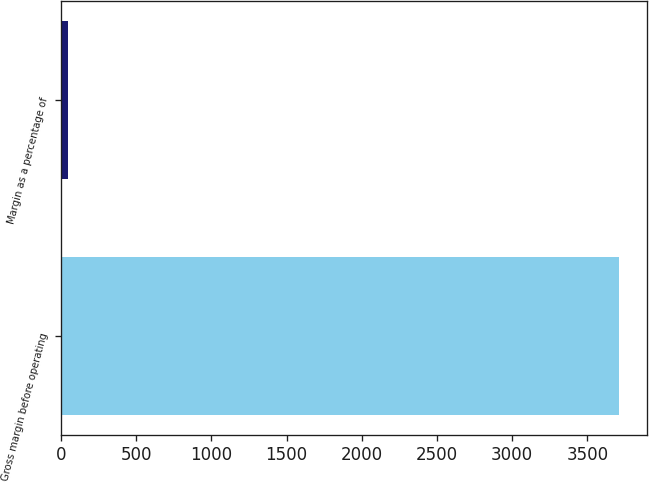<chart> <loc_0><loc_0><loc_500><loc_500><bar_chart><fcel>Gross margin before operating<fcel>Margin as a percentage of<nl><fcel>3711<fcel>45.7<nl></chart> 